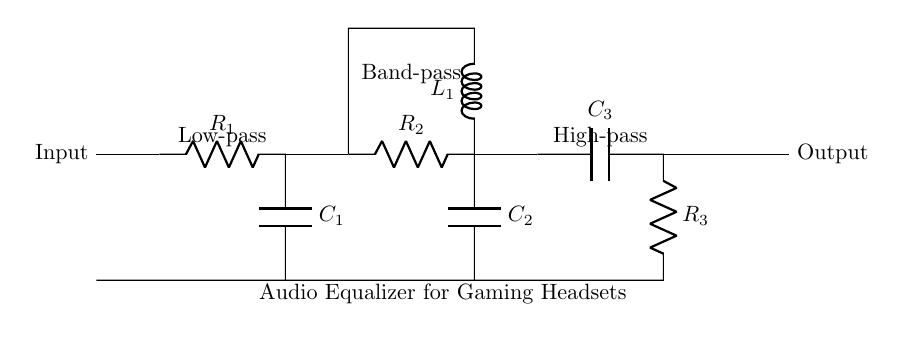What is the input component? The input component is represented by the initial connection in the circuit diagram, which is a signal input before any filtering occurs.
Answer: Input What type of filter is used at the beginning of the circuit? The circuit initially employs a low-pass filter, which is indicated by the resistor and capacitor configuration immediately after the input.
Answer: Low-pass What is the role of the band-pass filter? The band-pass filter allows a specific range of frequencies to pass while attenuating frequencies outside that range, consisting of a resistor, capacitor, and inductor in combination.
Answer: Frequency range selection Which components form the high-pass filter in the circuit? The high-pass filter combines a capacitor at the input followed by a resistor, allowing high-frequency signals to pass while blocking low-frequency ones.
Answer: Capacitor and resistor What is the output of the audio equalizer? The output of the audio equalizer is the final connection in the circuit that carries the filtered audio signal to the headphones or audio playback device.
Answer: Output How many types of filters are present in this circuit? The circuit contains three types of filters: low-pass, band-pass, and high-pass, as indicated by their individual configurations and labels within the schematic.
Answer: Three 